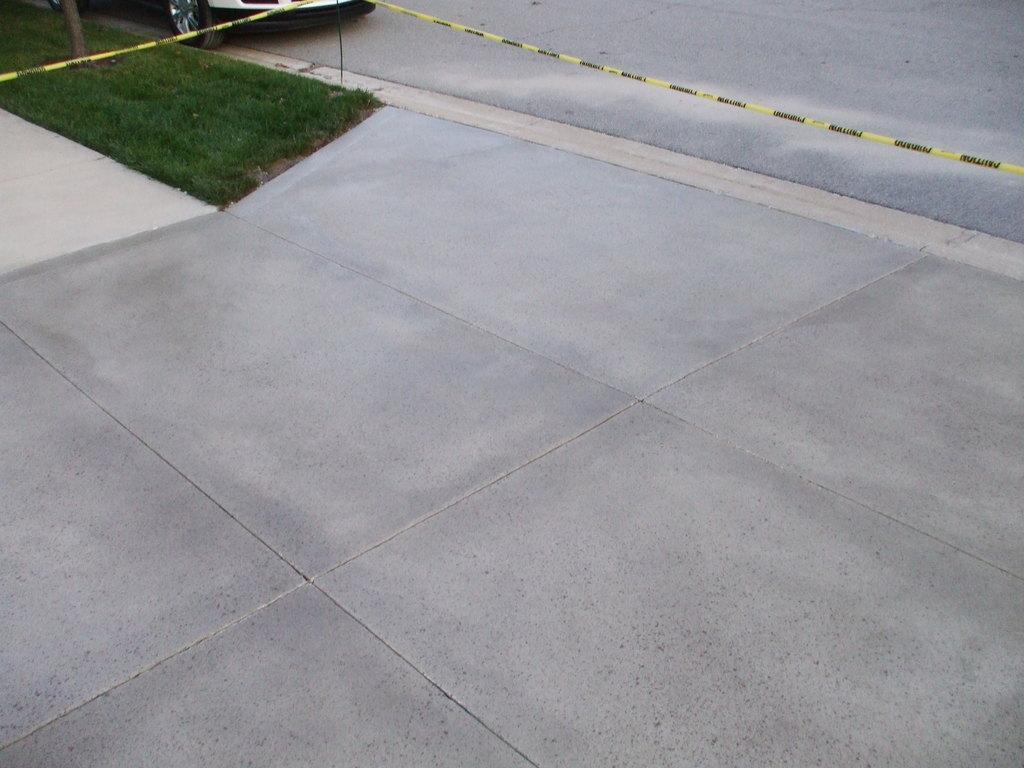How would you summarize this image in a sentence or two? In this picture we can see road and granite floor. At top left corner there is a car near to the grass. 